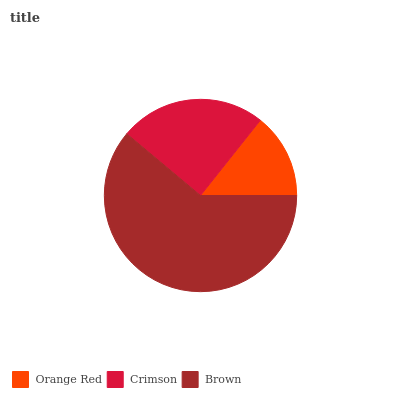Is Orange Red the minimum?
Answer yes or no. Yes. Is Brown the maximum?
Answer yes or no. Yes. Is Crimson the minimum?
Answer yes or no. No. Is Crimson the maximum?
Answer yes or no. No. Is Crimson greater than Orange Red?
Answer yes or no. Yes. Is Orange Red less than Crimson?
Answer yes or no. Yes. Is Orange Red greater than Crimson?
Answer yes or no. No. Is Crimson less than Orange Red?
Answer yes or no. No. Is Crimson the high median?
Answer yes or no. Yes. Is Crimson the low median?
Answer yes or no. Yes. Is Orange Red the high median?
Answer yes or no. No. Is Orange Red the low median?
Answer yes or no. No. 